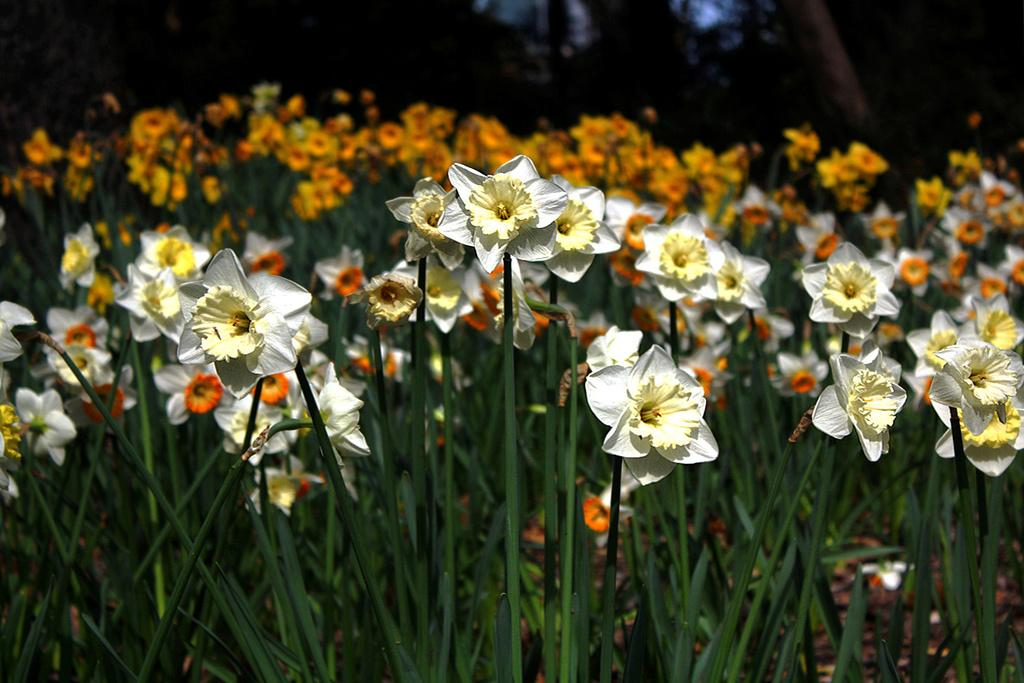What type of living organisms can be seen in the image? There are plants with flowers in the image. What can be observed about the background of the image? The background of the image is dark. What type of drug is being administered to the plants in the image? There is no indication of any drug being administered to the plants in the image. 